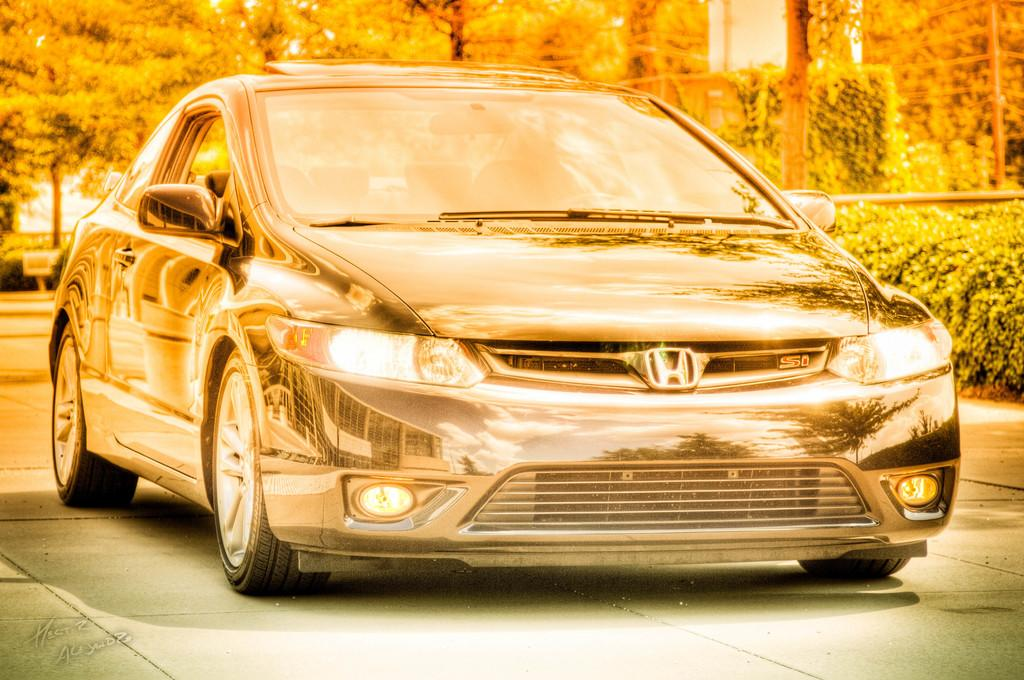How has the image been altered or modified? The image is edited. What can be seen on the ground in the image? There is a car on the ground. What type of natural environment is visible in the background? There are many trees in the background. What type of vegetation is present on the right side of the image? There are some plants on the right side of the image. What type of arch can be seen in the image? There is no arch present in the image. How many elbows are visible in the image? There are no elbows visible in the image. 